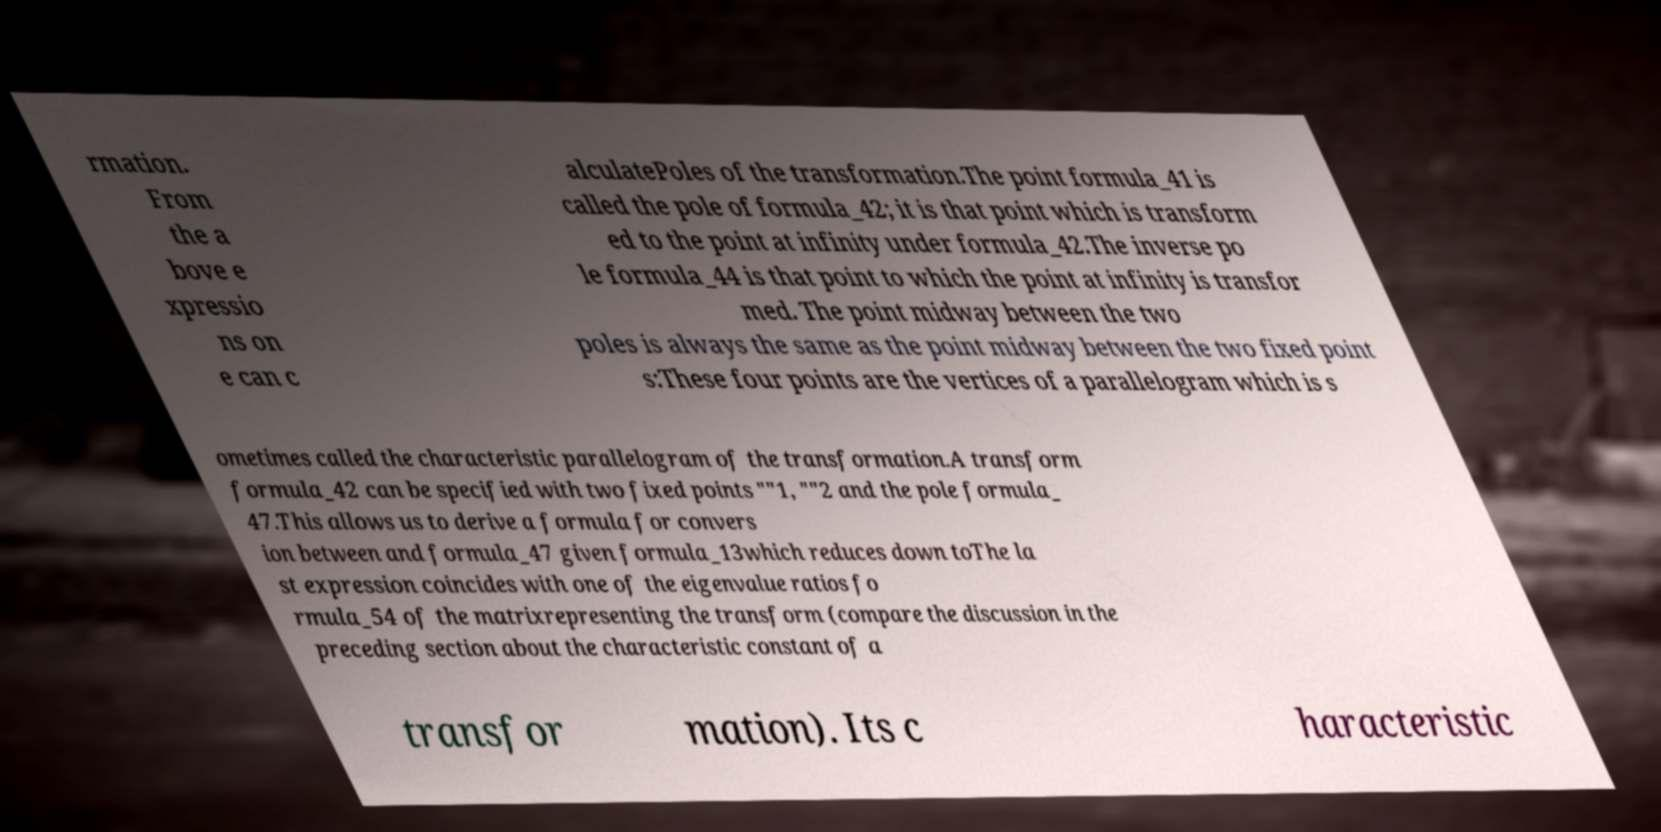Please identify and transcribe the text found in this image. rmation. From the a bove e xpressio ns on e can c alculatePoles of the transformation.The point formula_41 is called the pole of formula_42; it is that point which is transform ed to the point at infinity under formula_42.The inverse po le formula_44 is that point to which the point at infinity is transfor med. The point midway between the two poles is always the same as the point midway between the two fixed point s:These four points are the vertices of a parallelogram which is s ometimes called the characteristic parallelogram of the transformation.A transform formula_42 can be specified with two fixed points ""1, ""2 and the pole formula_ 47.This allows us to derive a formula for convers ion between and formula_47 given formula_13which reduces down toThe la st expression coincides with one of the eigenvalue ratios fo rmula_54 of the matrixrepresenting the transform (compare the discussion in the preceding section about the characteristic constant of a transfor mation). Its c haracteristic 